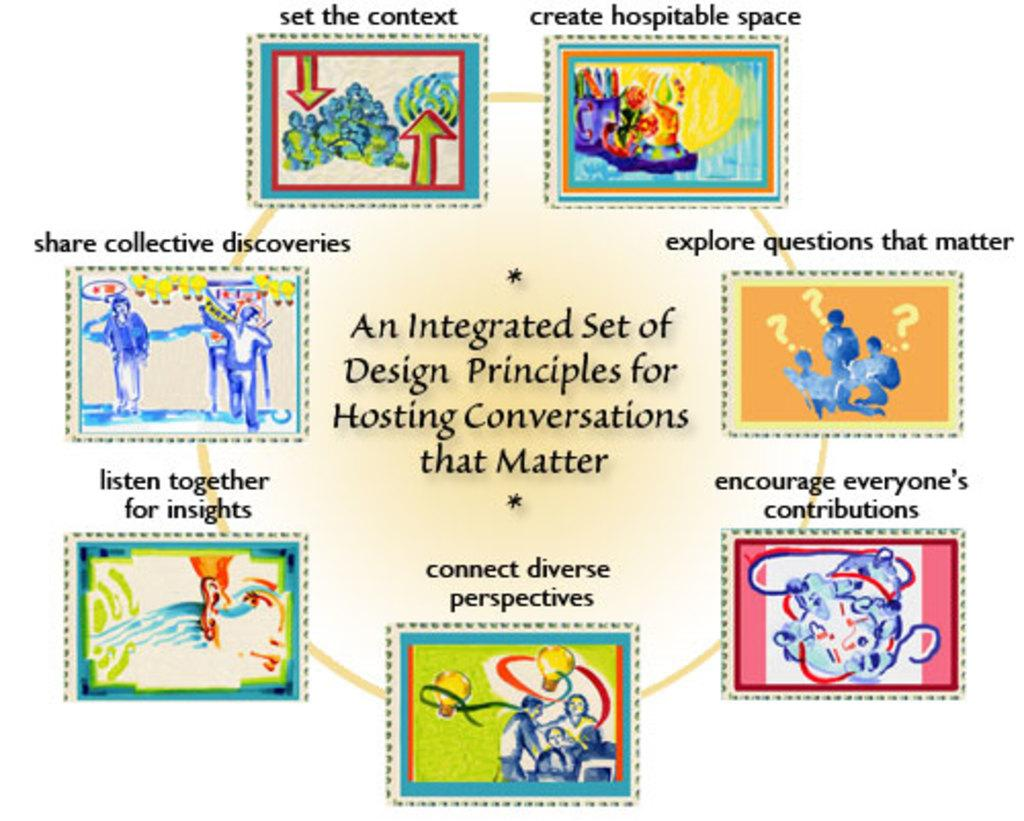<image>
Present a compact description of the photo's key features. Informational circle that shows an integrated set of design principles for hosting conversations that matter. 